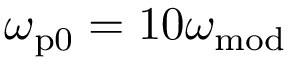Convert formula to latex. <formula><loc_0><loc_0><loc_500><loc_500>\omega _ { p 0 } = 1 0 \omega _ { m o d }</formula> 